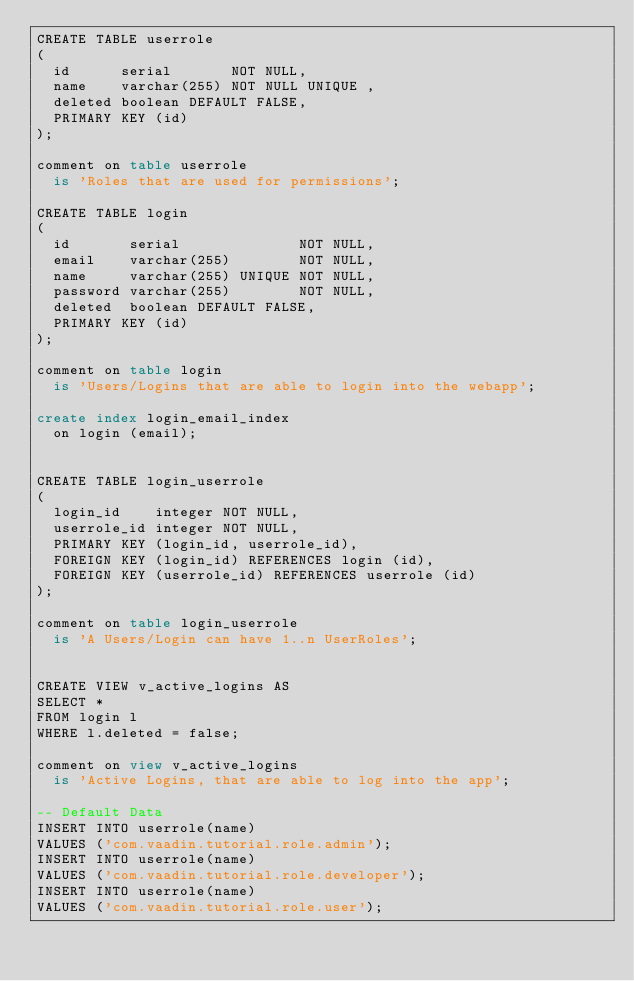Convert code to text. <code><loc_0><loc_0><loc_500><loc_500><_SQL_>CREATE TABLE userrole
(
  id      serial       NOT NULL,
  name    varchar(255) NOT NULL UNIQUE ,
  deleted boolean DEFAULT FALSE,
  PRIMARY KEY (id)
);

comment on table userrole
  is 'Roles that are used for permissions';

CREATE TABLE login
(
  id       serial              NOT NULL,
  email    varchar(255)        NOT NULL,
  name     varchar(255) UNIQUE NOT NULL,
  password varchar(255)        NOT NULL,
  deleted  boolean DEFAULT FALSE,
  PRIMARY KEY (id)
);

comment on table login
  is 'Users/Logins that are able to login into the webapp';

create index login_email_index
  on login (email);


CREATE TABLE login_userrole
(
  login_id    integer NOT NULL,
  userrole_id integer NOT NULL,
  PRIMARY KEY (login_id, userrole_id),
  FOREIGN KEY (login_id) REFERENCES login (id),
  FOREIGN KEY (userrole_id) REFERENCES userrole (id)
);

comment on table login_userrole
  is 'A Users/Login can have 1..n UserRoles';


CREATE VIEW v_active_logins AS
SELECT *
FROM login l
WHERE l.deleted = false;

comment on view v_active_logins
  is 'Active Logins, that are able to log into the app';

-- Default Data
INSERT INTO userrole(name)
VALUES ('com.vaadin.tutorial.role.admin');
INSERT INTO userrole(name)
VALUES ('com.vaadin.tutorial.role.developer');
INSERT INTO userrole(name)
VALUES ('com.vaadin.tutorial.role.user');

</code> 